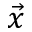Convert formula to latex. <formula><loc_0><loc_0><loc_500><loc_500>\vec { x }</formula> 